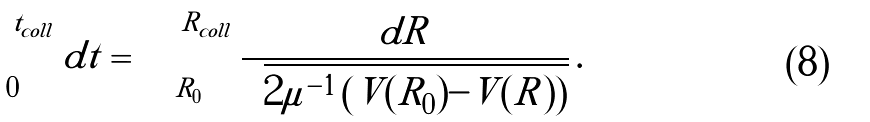Convert formula to latex. <formula><loc_0><loc_0><loc_500><loc_500>\int _ { 0 } ^ { t _ { c o l l } } d t = \int _ { R _ { 0 } } ^ { R _ { c o l l } } \frac { d R } { \sqrt { 2 \mu ^ { - 1 } \left ( V ( R _ { 0 } ) - V ( R ) \right ) } } \, .</formula> 